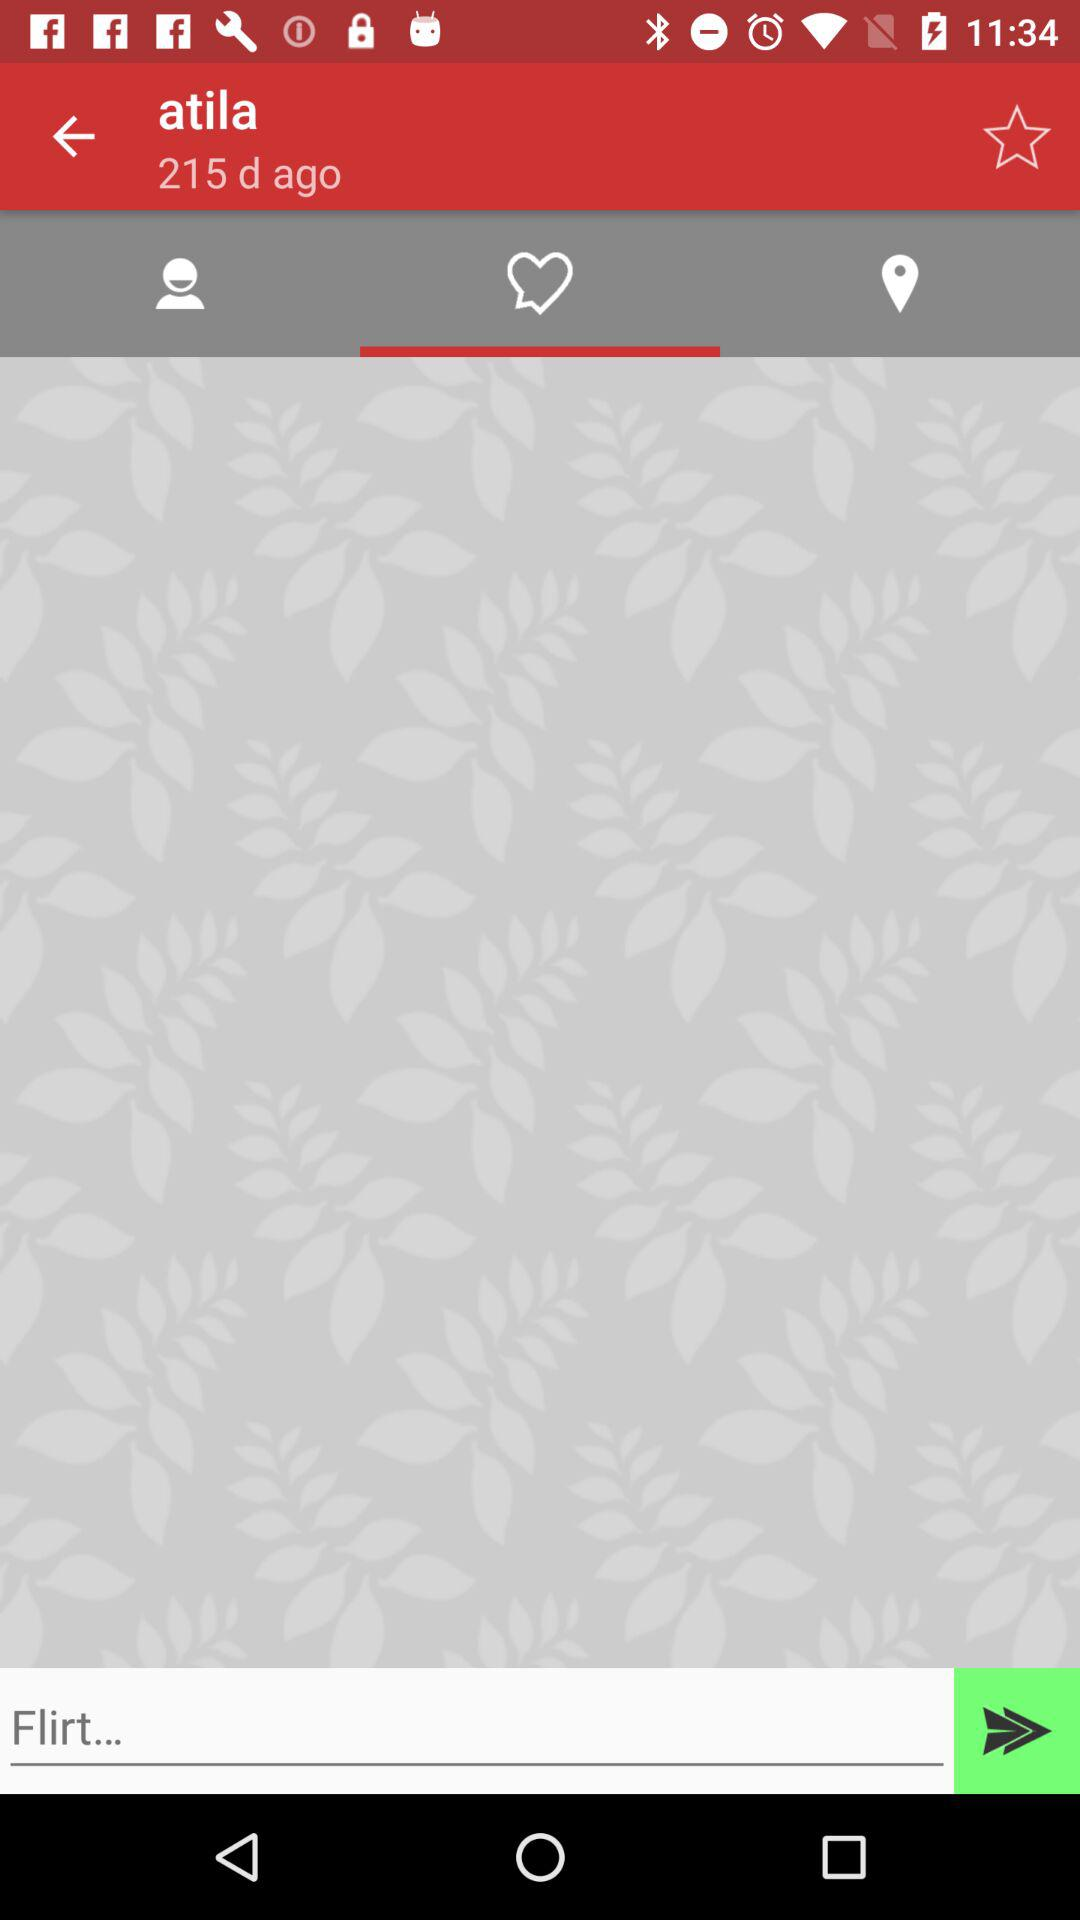Which tab is selected? The selected tab is "Love Chat". 